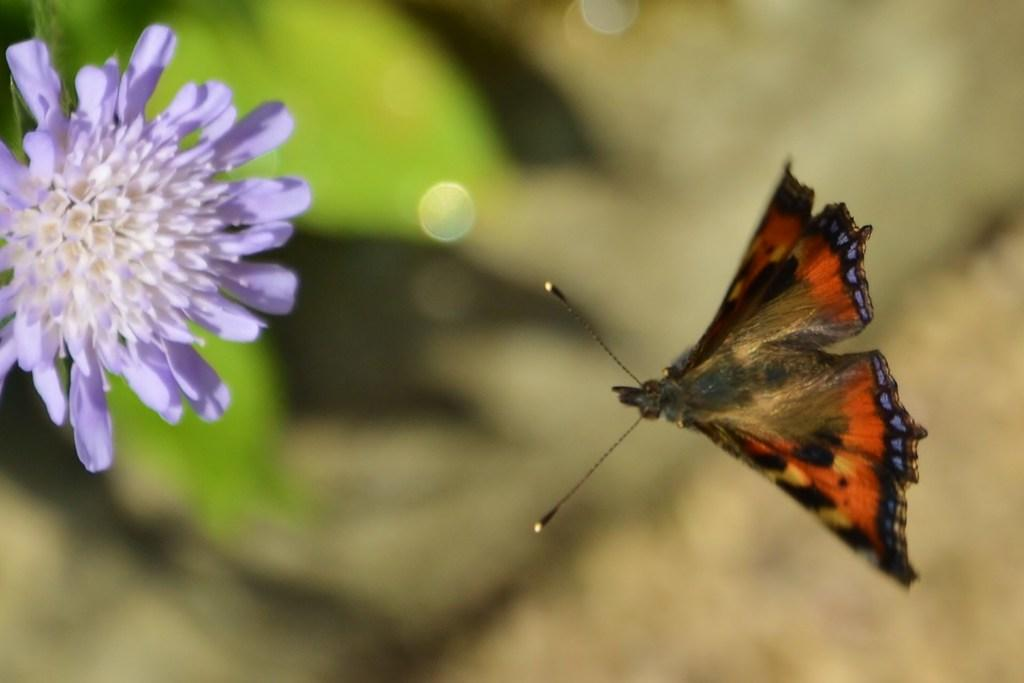What type of insect can be seen on the right side of the image? There is a butterfly on the right side of the image. What type of plant is on the left side of the image? There is a flower on the left side of the image. What else is present on the left side of the image besides the flower? Leaves are present on the left side of the image. How would you describe the background of the image? The background of the image is blurry. Can you tell me how many bones are visible in the image? There are no bones present in the image. What type of snail can be seen crawling on the flower in the image? There is no snail present in the image; it only features a butterfly and a flower. 